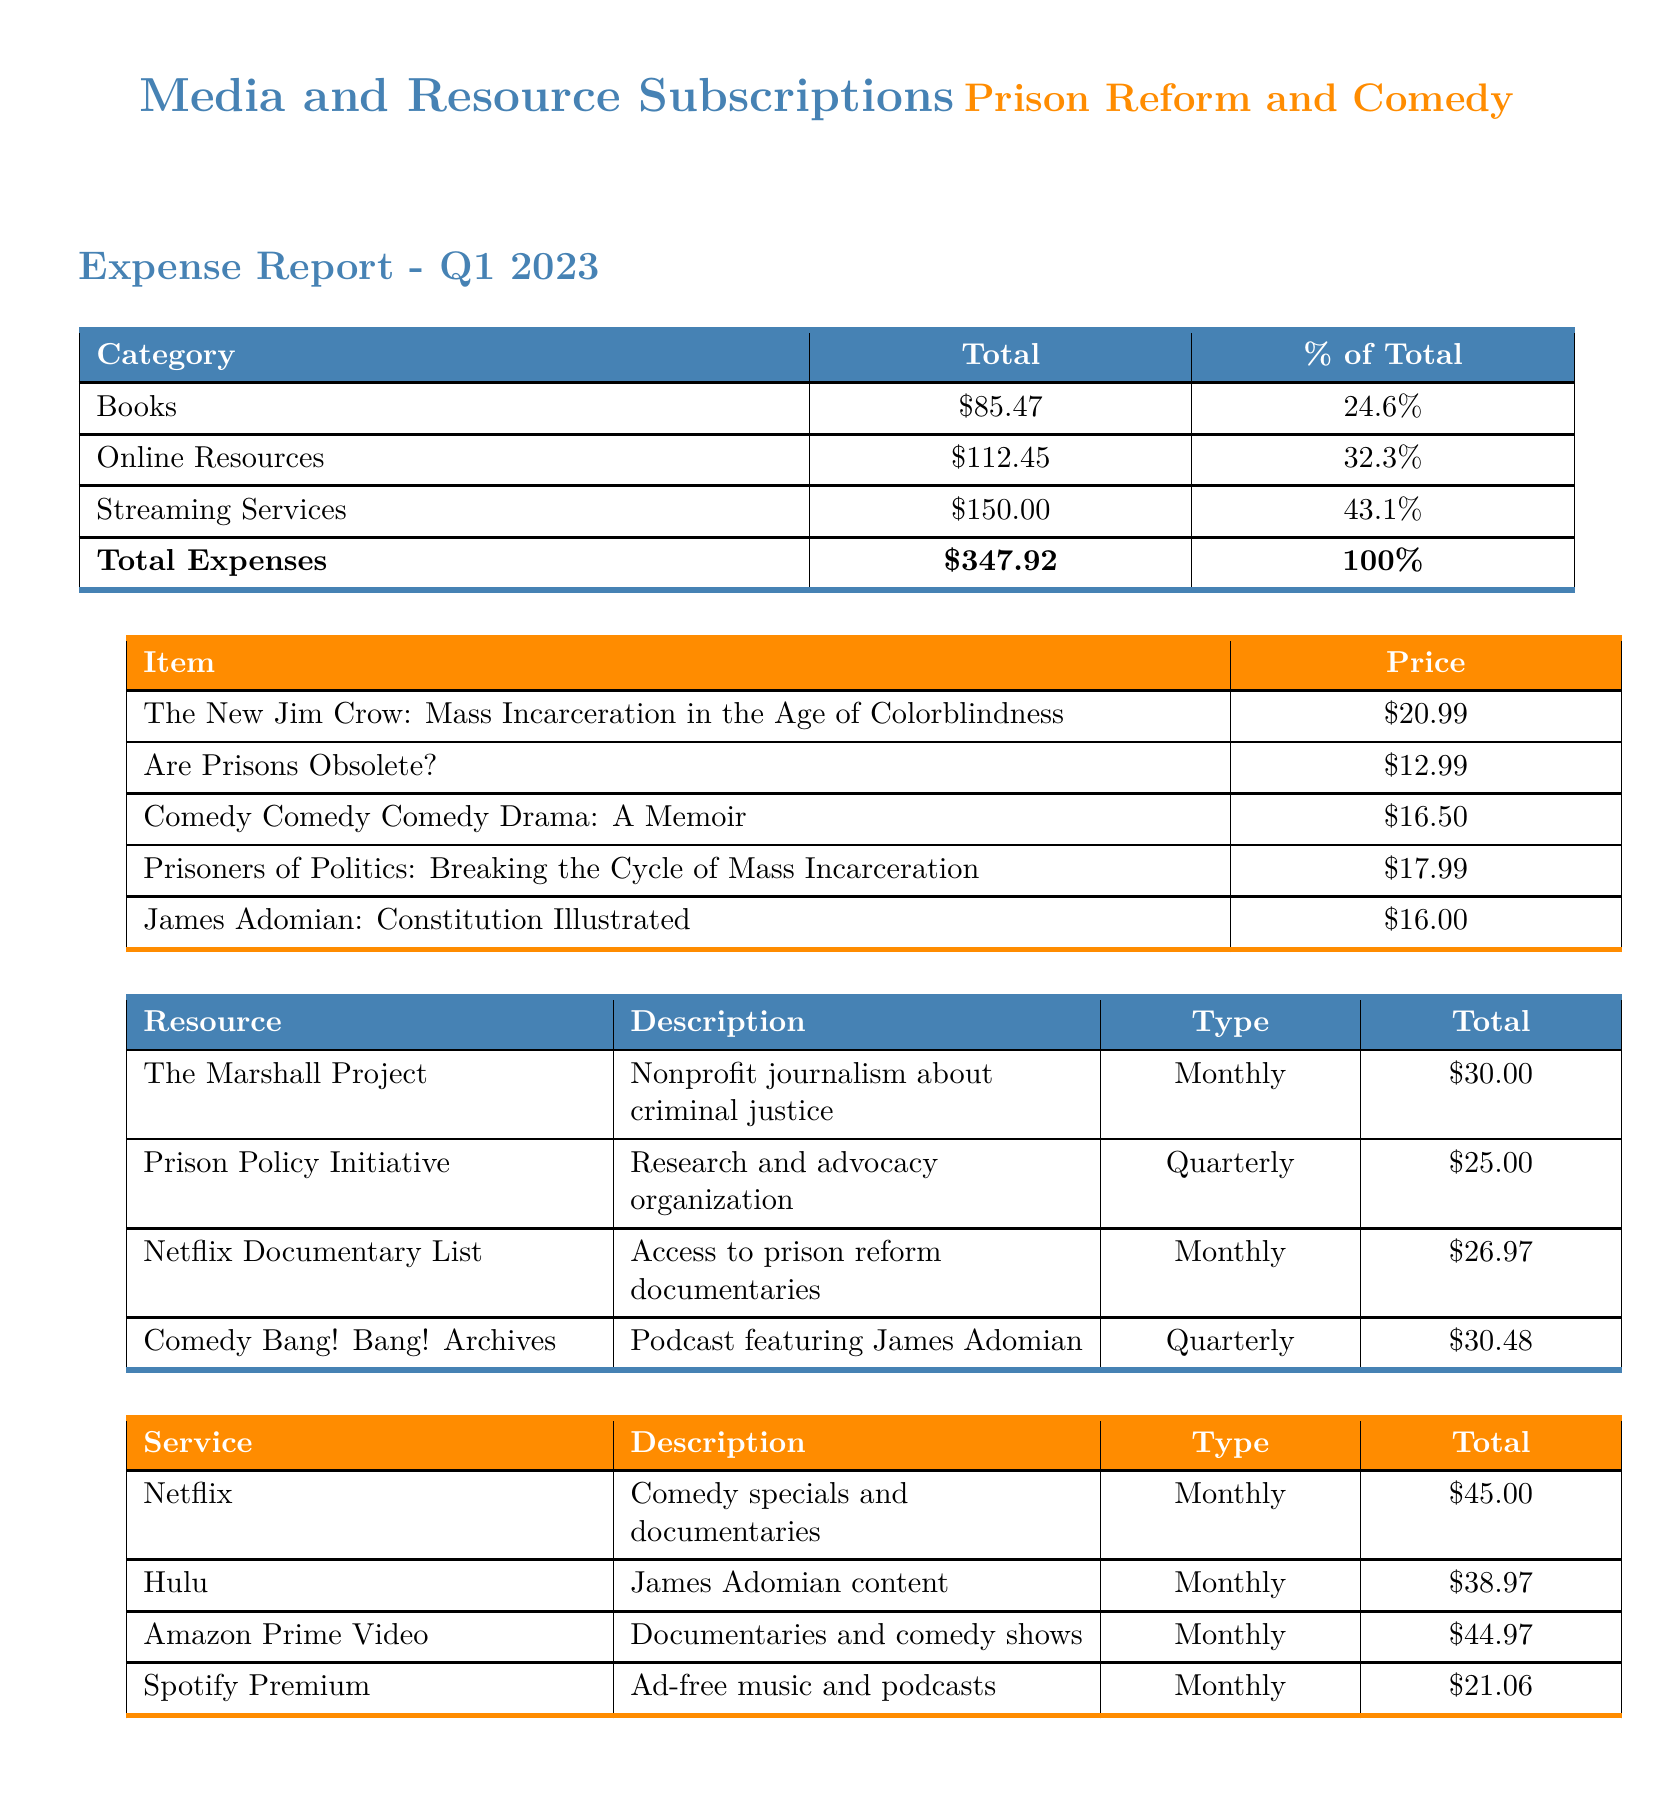what is the total amount spent on books? The total amount spent on books is detailed in the first table under the "Total" column for the "Books" category, which is $85.47.
Answer: $85.47 what percentage of total expenses is allocated to online resources? The percentage of total expenses for online resources is shown in the first table under the "% of Total" column for the "Online Resources" category, which is 32.3%.
Answer: 32.3% name one book included in the expense report. The expense report lists multiple books, one of which is "The New Jim Crow: Mass Incarceration in the Age of Colorblindness" found in the second table under "Item".
Answer: The New Jim Crow: Mass Incarceration in the Age of Colorblindness what is the total cost of the streaming services? The total cost for streaming services is provided in the first table under the "Total" column for the "Streaming Services" category, which is $150.00.
Answer: $150.00 how much is spent monthly on The Marshall Project? The expense report specifies that the cost for The Marshall Project is listed as $30.00 in the third table under the "Total" column.
Answer: $30.00 what type of resource is the Prison Policy Initiative? The type of resource for the Prison Policy Initiative is defined in the third table as a "Research and advocacy organization."
Answer: Research and advocacy organization which streaming service has the highest total cost? The streaming service with the highest total cost can be determined by comparing the totals in the fourth table, which shows Netflix at $45.00.
Answer: Netflix how many resources are listed in the report? The report details four resources in the third table, therefore the total count is four.
Answer: Four which comedy podcast features James Adomian? The relevant podcast featuring James Adomian is named "Comedy Bang! Bang! Archives," as mentioned in the third table under "Resource".
Answer: Comedy Bang! Bang! Archives 